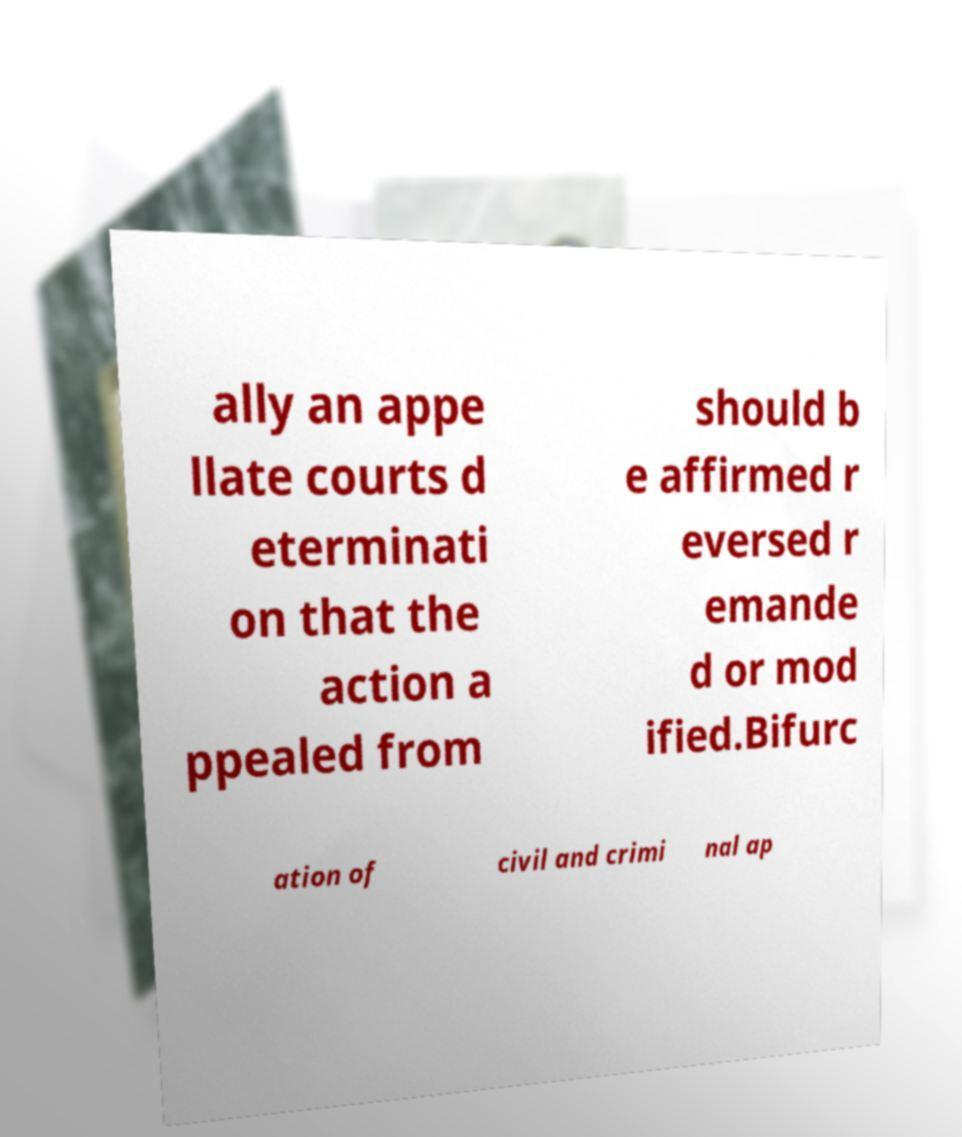There's text embedded in this image that I need extracted. Can you transcribe it verbatim? ally an appe llate courts d eterminati on that the action a ppealed from should b e affirmed r eversed r emande d or mod ified.Bifurc ation of civil and crimi nal ap 